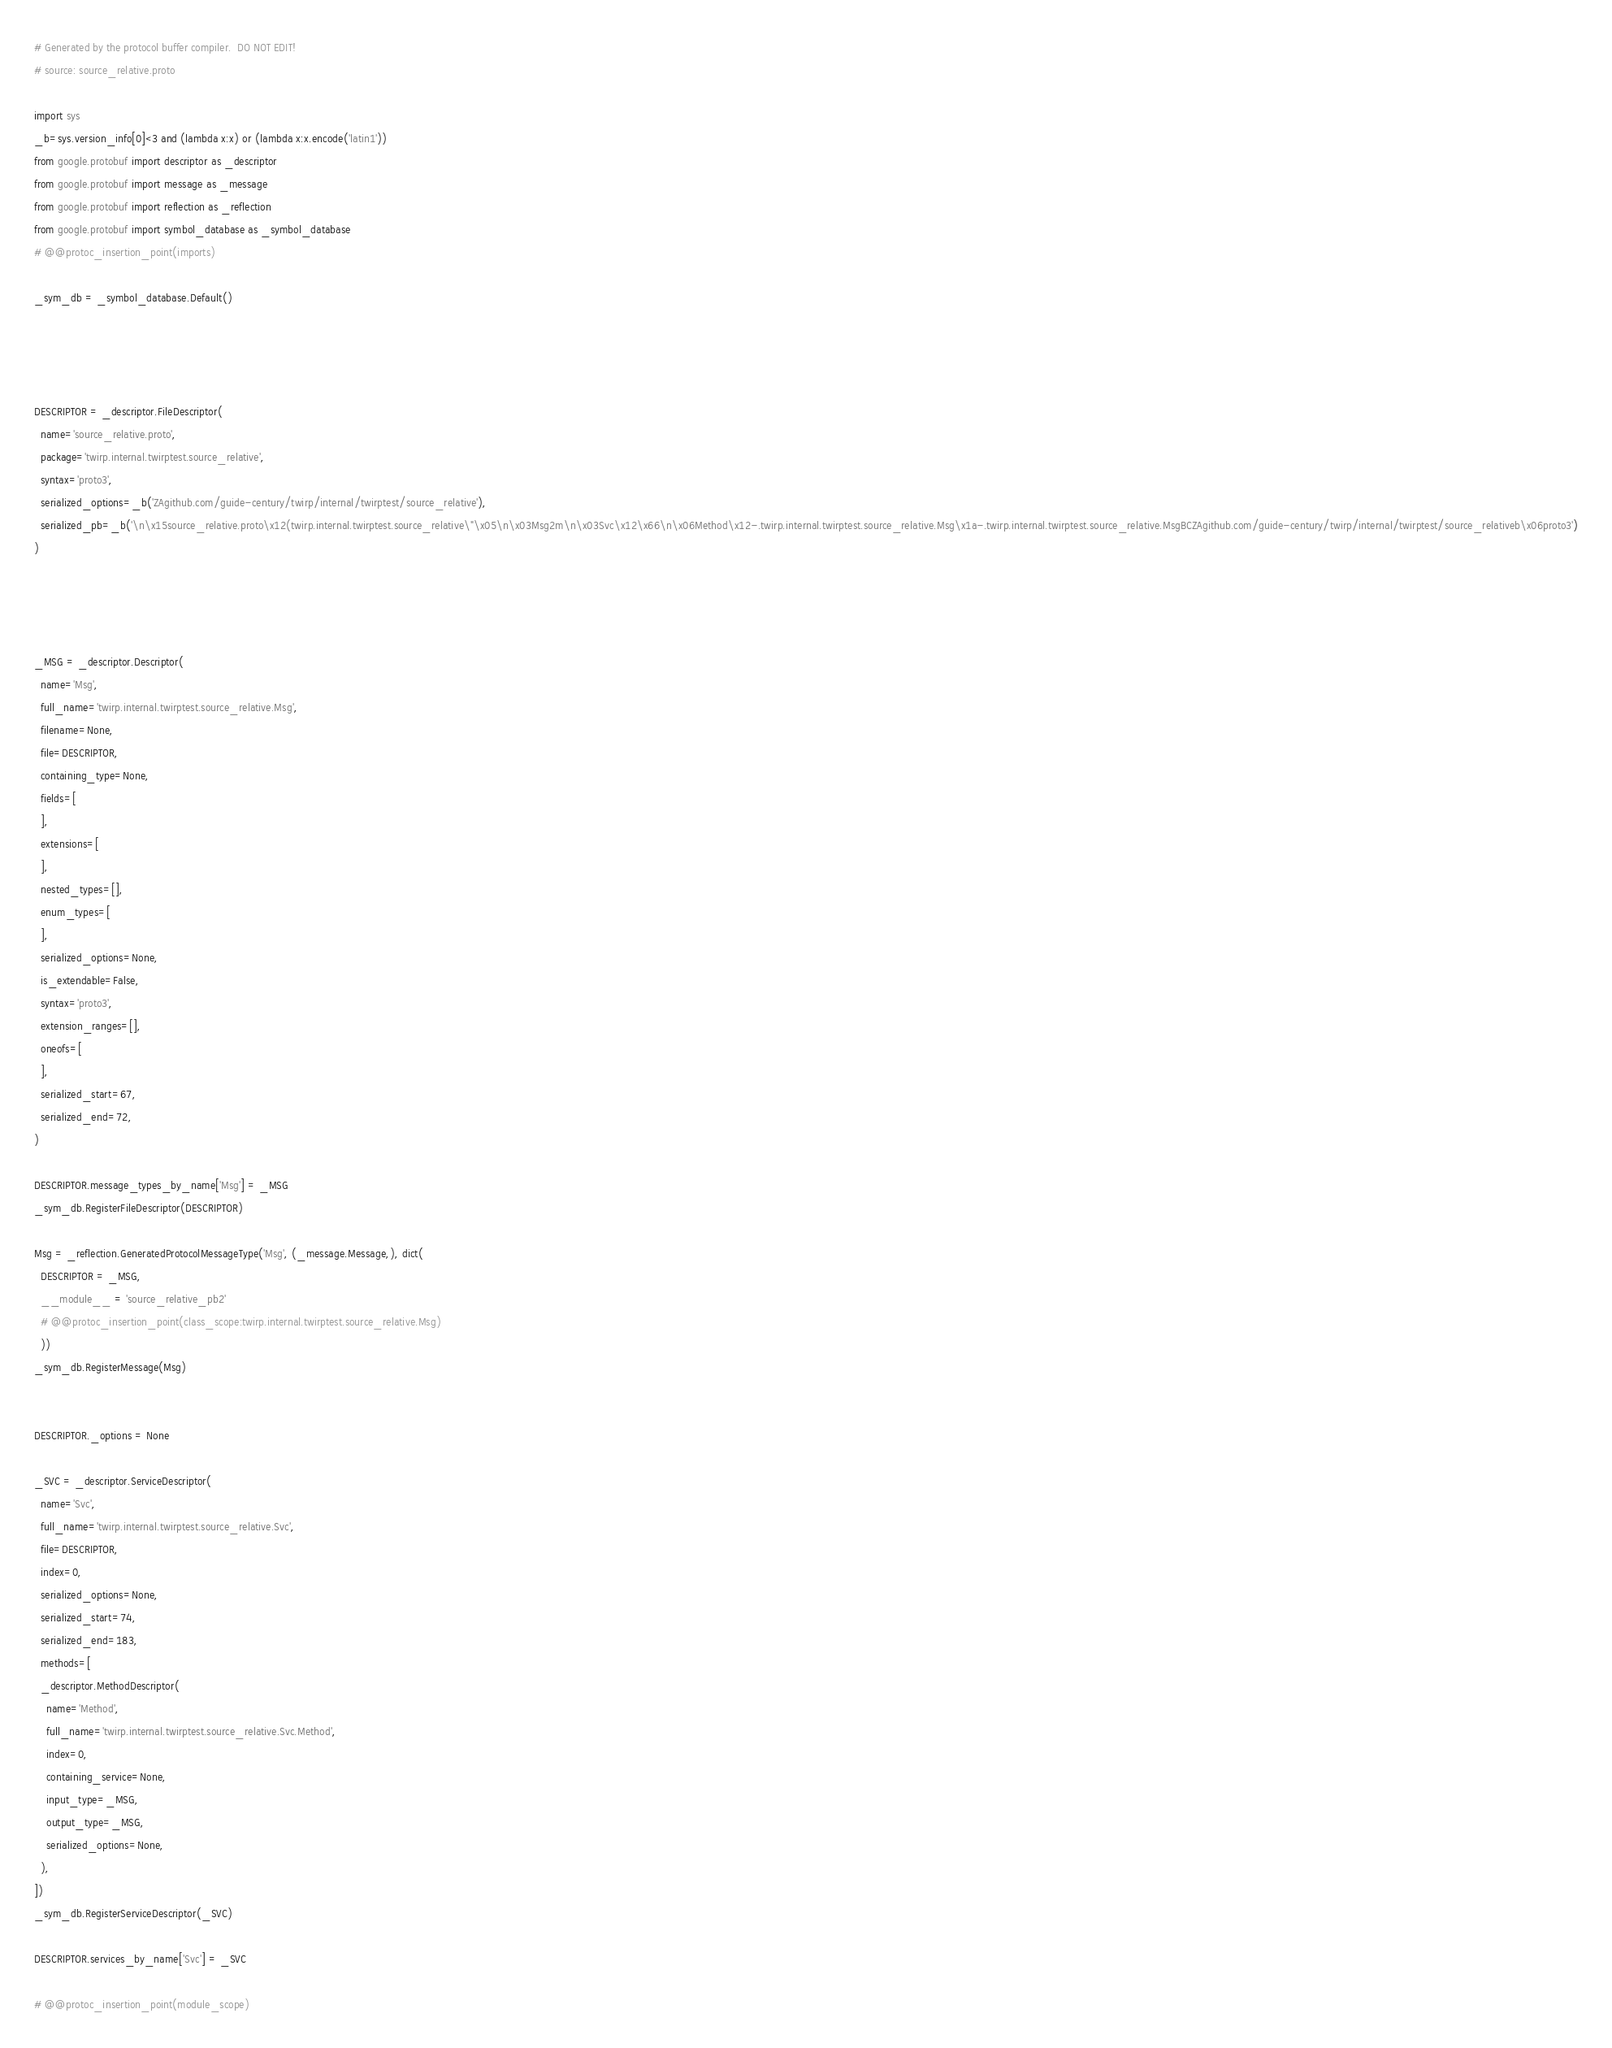Convert code to text. <code><loc_0><loc_0><loc_500><loc_500><_Python_># Generated by the protocol buffer compiler.  DO NOT EDIT!
# source: source_relative.proto

import sys
_b=sys.version_info[0]<3 and (lambda x:x) or (lambda x:x.encode('latin1'))
from google.protobuf import descriptor as _descriptor
from google.protobuf import message as _message
from google.protobuf import reflection as _reflection
from google.protobuf import symbol_database as _symbol_database
# @@protoc_insertion_point(imports)

_sym_db = _symbol_database.Default()




DESCRIPTOR = _descriptor.FileDescriptor(
  name='source_relative.proto',
  package='twirp.internal.twirptest.source_relative',
  syntax='proto3',
  serialized_options=_b('ZAgithub.com/guide-century/twirp/internal/twirptest/source_relative'),
  serialized_pb=_b('\n\x15source_relative.proto\x12(twirp.internal.twirptest.source_relative\"\x05\n\x03Msg2m\n\x03Svc\x12\x66\n\x06Method\x12-.twirp.internal.twirptest.source_relative.Msg\x1a-.twirp.internal.twirptest.source_relative.MsgBCZAgithub.com/guide-century/twirp/internal/twirptest/source_relativeb\x06proto3')
)




_MSG = _descriptor.Descriptor(
  name='Msg',
  full_name='twirp.internal.twirptest.source_relative.Msg',
  filename=None,
  file=DESCRIPTOR,
  containing_type=None,
  fields=[
  ],
  extensions=[
  ],
  nested_types=[],
  enum_types=[
  ],
  serialized_options=None,
  is_extendable=False,
  syntax='proto3',
  extension_ranges=[],
  oneofs=[
  ],
  serialized_start=67,
  serialized_end=72,
)

DESCRIPTOR.message_types_by_name['Msg'] = _MSG
_sym_db.RegisterFileDescriptor(DESCRIPTOR)

Msg = _reflection.GeneratedProtocolMessageType('Msg', (_message.Message,), dict(
  DESCRIPTOR = _MSG,
  __module__ = 'source_relative_pb2'
  # @@protoc_insertion_point(class_scope:twirp.internal.twirptest.source_relative.Msg)
  ))
_sym_db.RegisterMessage(Msg)


DESCRIPTOR._options = None

_SVC = _descriptor.ServiceDescriptor(
  name='Svc',
  full_name='twirp.internal.twirptest.source_relative.Svc',
  file=DESCRIPTOR,
  index=0,
  serialized_options=None,
  serialized_start=74,
  serialized_end=183,
  methods=[
  _descriptor.MethodDescriptor(
    name='Method',
    full_name='twirp.internal.twirptest.source_relative.Svc.Method',
    index=0,
    containing_service=None,
    input_type=_MSG,
    output_type=_MSG,
    serialized_options=None,
  ),
])
_sym_db.RegisterServiceDescriptor(_SVC)

DESCRIPTOR.services_by_name['Svc'] = _SVC

# @@protoc_insertion_point(module_scope)
</code> 